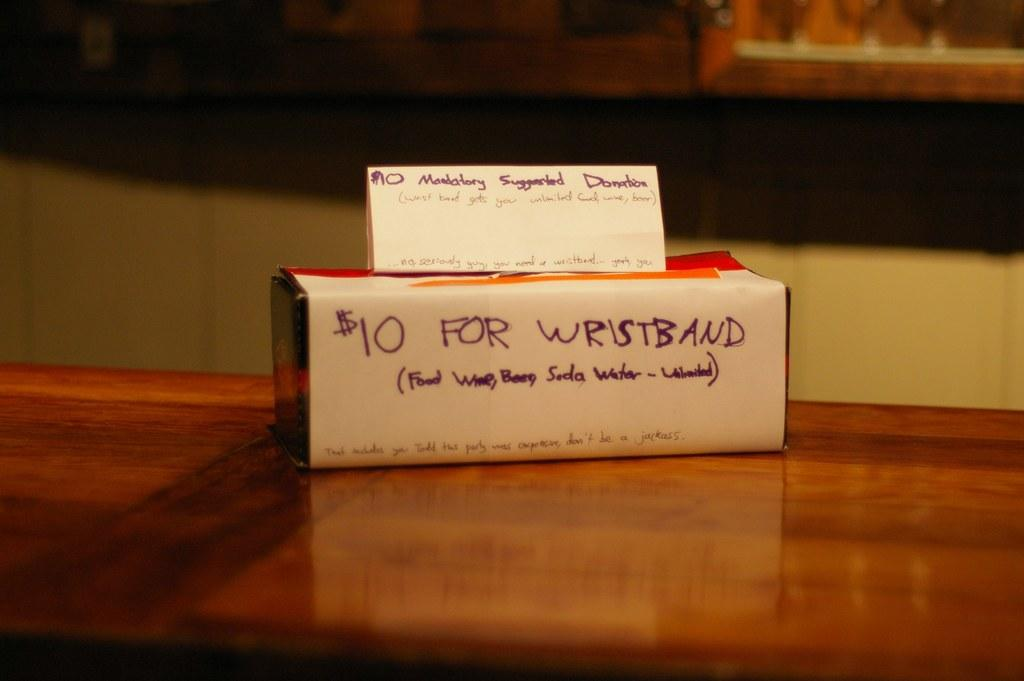<image>
Create a compact narrative representing the image presented. Sign that says ten dollars for wristband on the front 